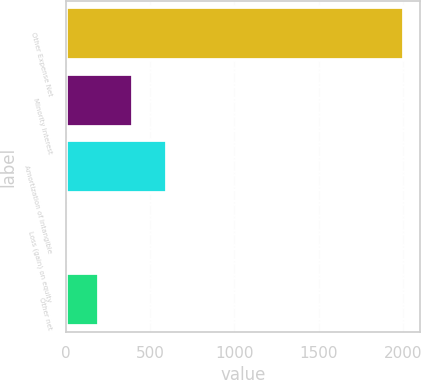Convert chart. <chart><loc_0><loc_0><loc_500><loc_500><bar_chart><fcel>Other Expense Net<fcel>Minority interest<fcel>Amortization of intangible<fcel>Loss (gain) on equity<fcel>Other net<nl><fcel>2001<fcel>400.36<fcel>600.44<fcel>0.2<fcel>200.28<nl></chart> 